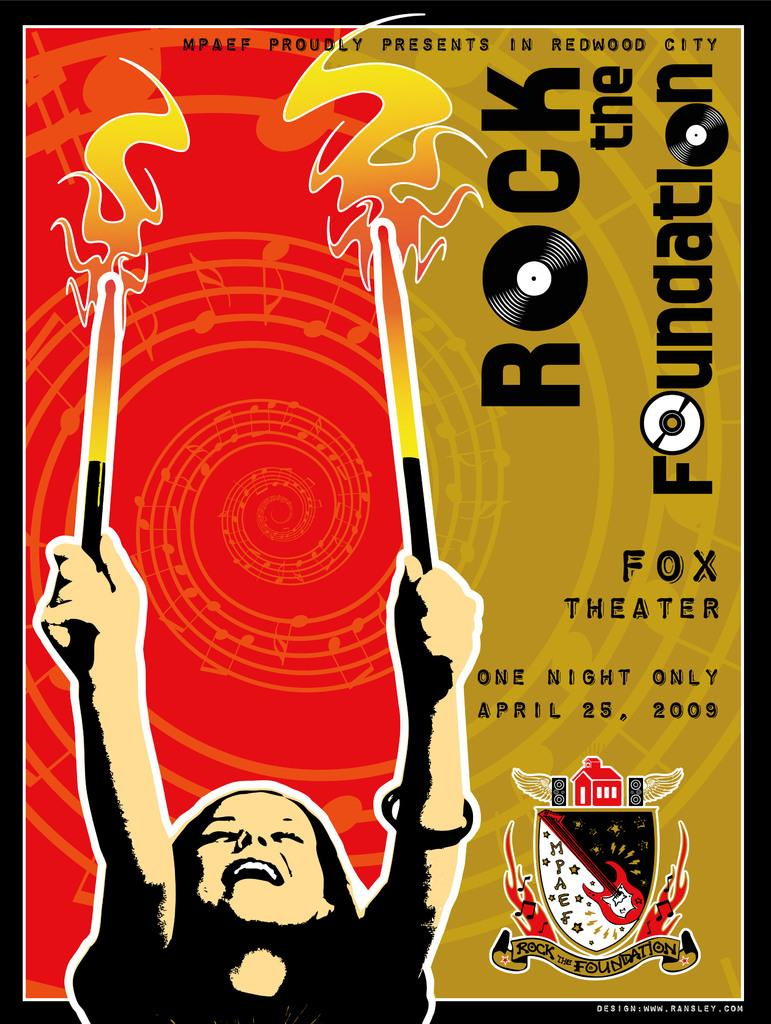<image>
Summarize the visual content of the image. poster for a rock and roll concert at the fox theater 